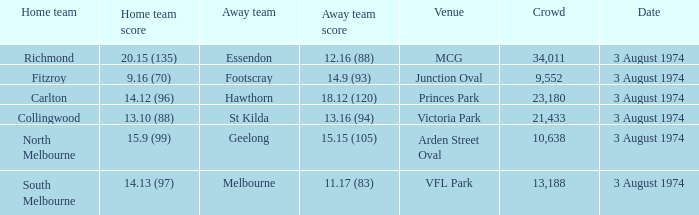Which Home team has a Venue of arden street oval? North Melbourne. 